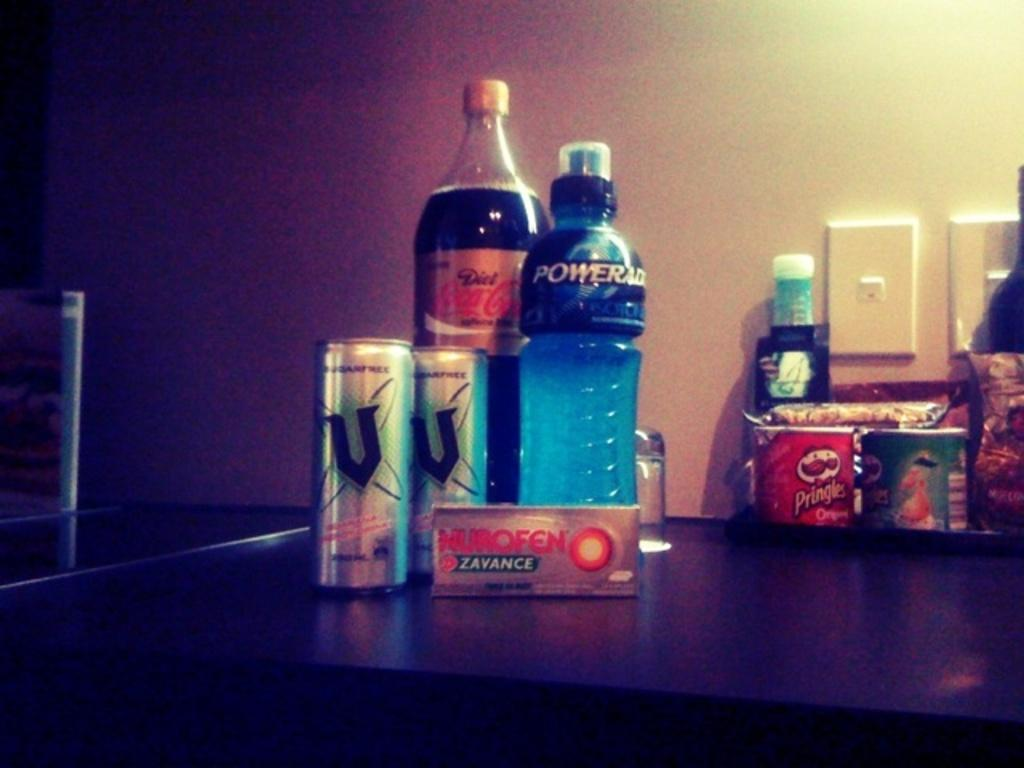<image>
Give a short and clear explanation of the subsequent image. Some snack food sits on a desk including Powerade, Coca Cola and some Pringles in the background. 